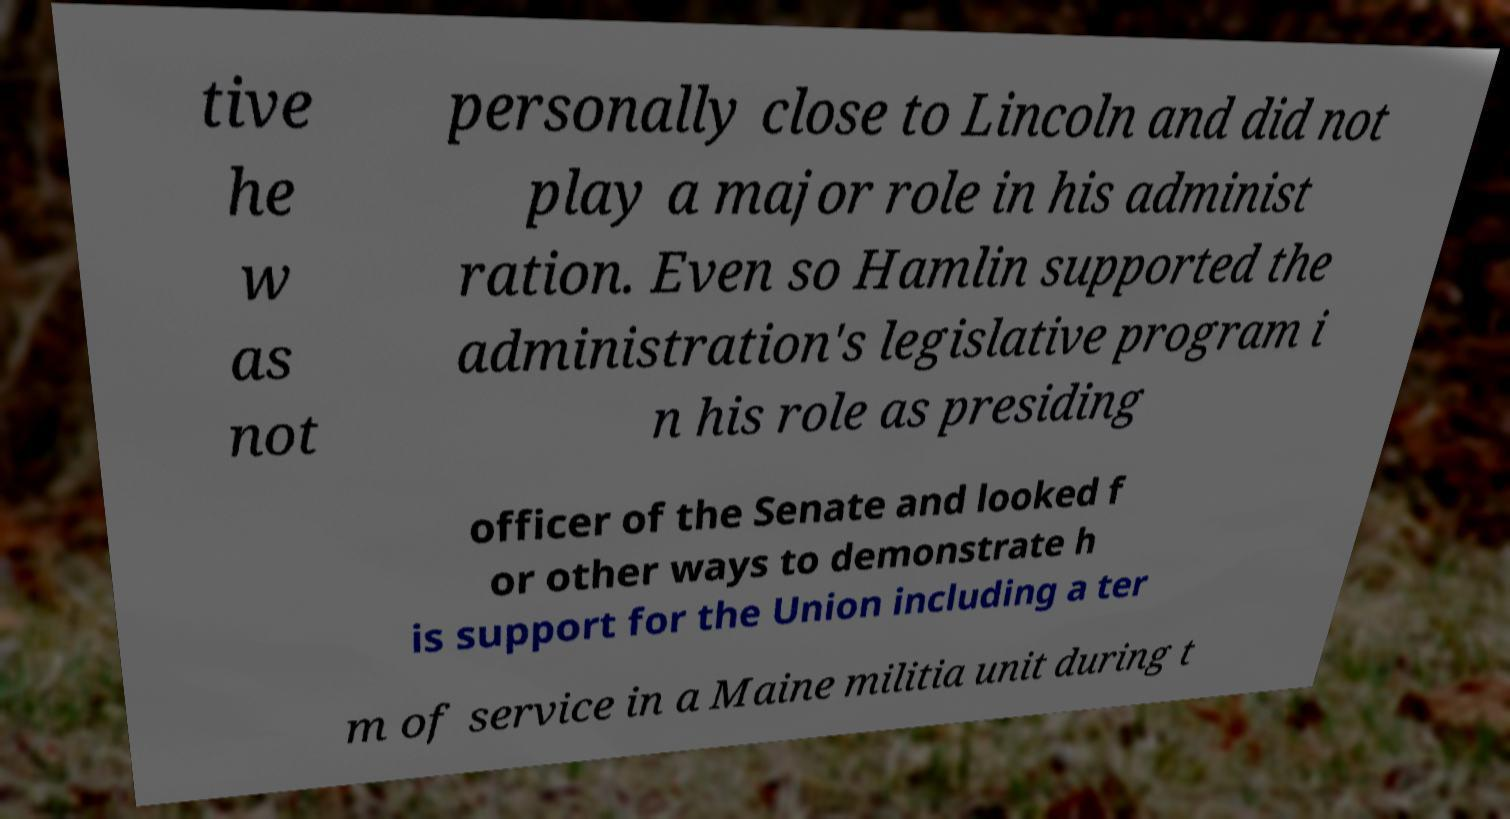Please identify and transcribe the text found in this image. tive he w as not personally close to Lincoln and did not play a major role in his administ ration. Even so Hamlin supported the administration's legislative program i n his role as presiding officer of the Senate and looked f or other ways to demonstrate h is support for the Union including a ter m of service in a Maine militia unit during t 